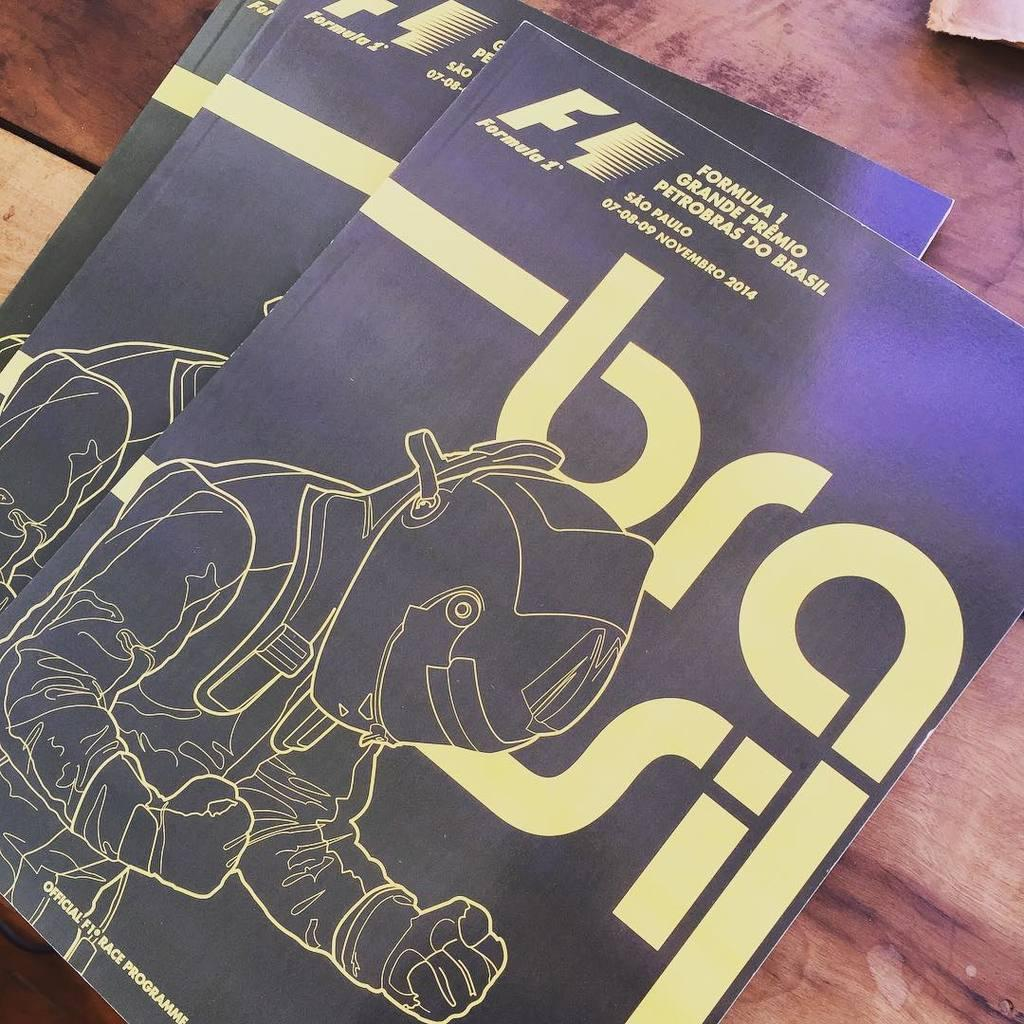<image>
Render a clear and concise summary of the photo. a person dressed up in a costume and a bra sign behind them 